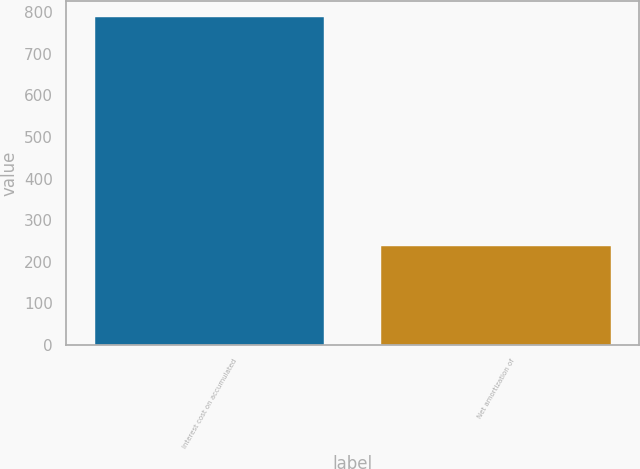Convert chart to OTSL. <chart><loc_0><loc_0><loc_500><loc_500><bar_chart><fcel>Interest cost on accumulated<fcel>Net amortization of<nl><fcel>788<fcel>239<nl></chart> 